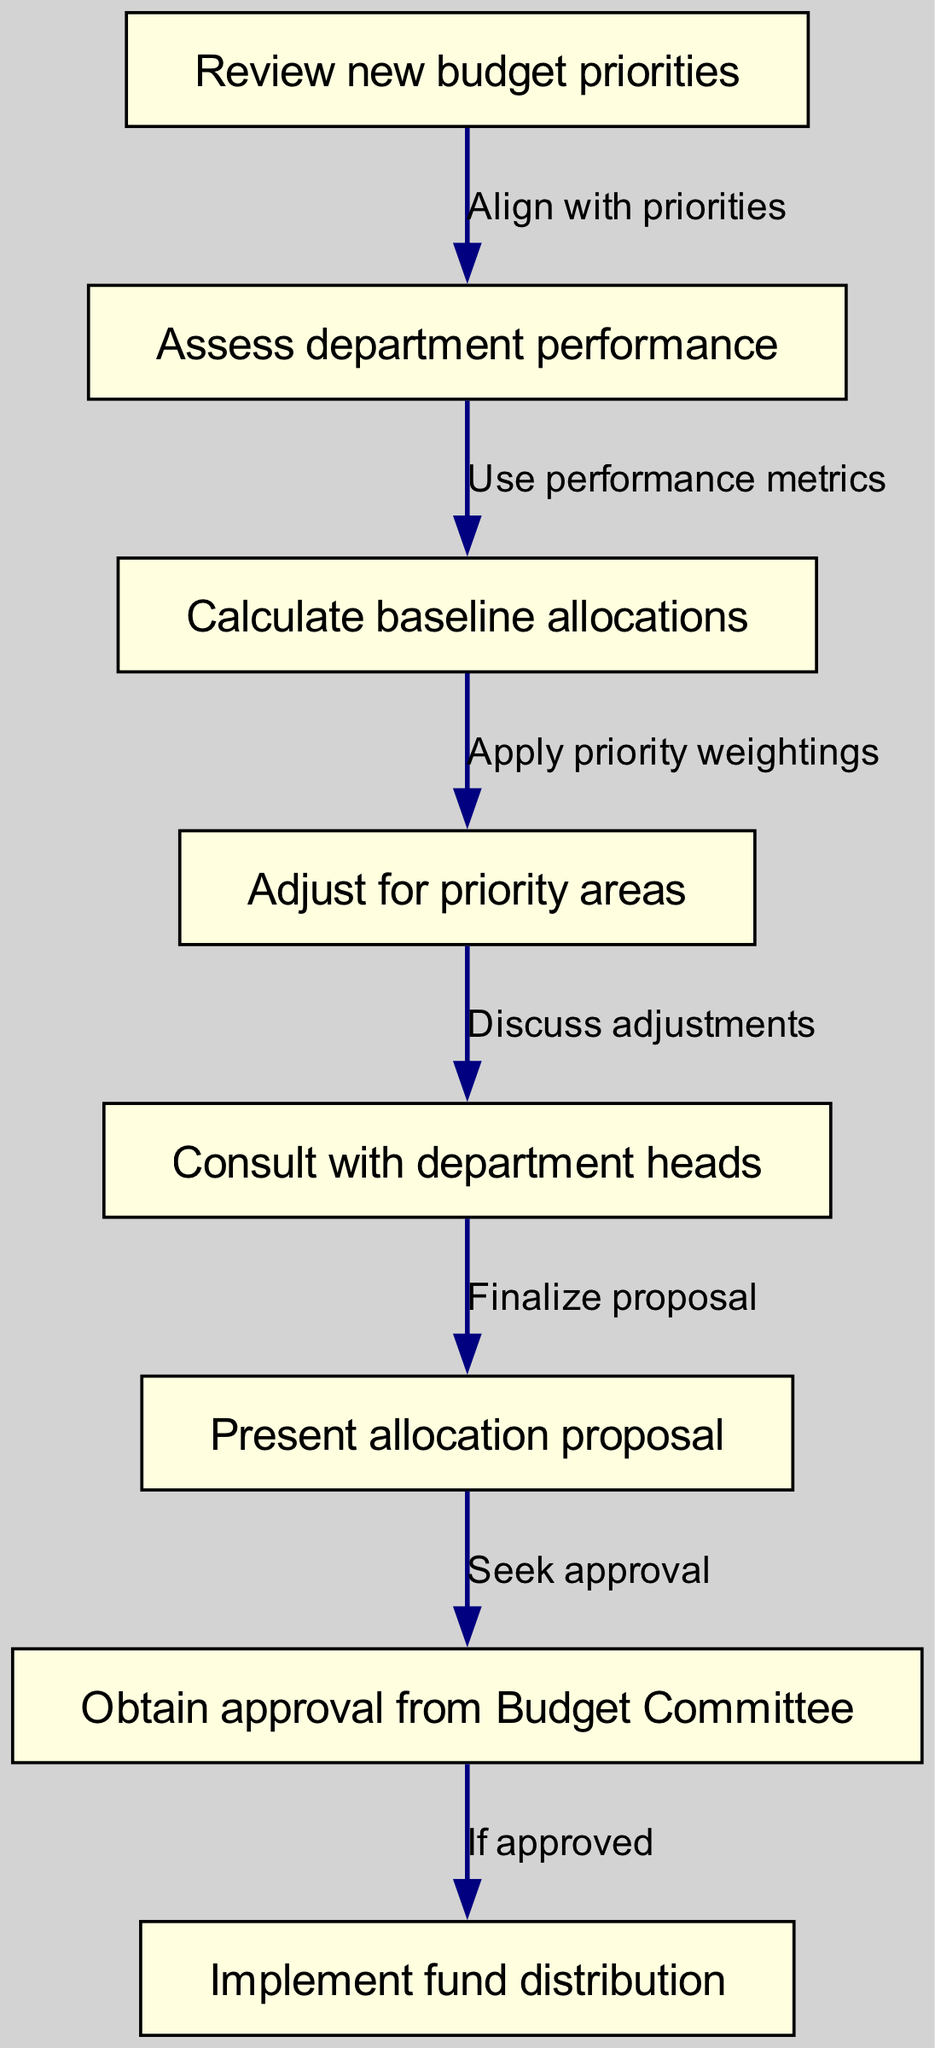What is the first step in the workflow? The first node in the diagram is "Review new budget priorities", which clearly indicates the initial action taken in this workflow.
Answer: Review new budget priorities How many nodes are present in this diagram? By counting the distinct entries listed in the "nodes" section, there are a total of eight nodes in the workflow diagram.
Answer: 8 What is the relationship between "Assess department performance" and "Calculate baseline allocations"? The edge connecting these two nodes states "Use performance metrics", showing that assessing performance directly influences the calculation of baseline allocations.
Answer: Use performance metrics What is the final step to be taken in this workflow? The last node in the diagram is "Implement fund distribution", indicating that this is the concluding action of the process.
Answer: Implement fund distribution Which step comes after "Consult with department heads"? Following the "Consult with department heads" node, the next step as indicated by the connecting edge is "Present allocation proposal".
Answer: Present allocation proposal If the proposal is approved, what is the subsequent action? The diagram indicates that "Implement fund distribution" follows "Obtain approval from Budget Committee" if the proposal is approved.
Answer: Implement fund distribution What identifies the adjustments needed in the funding allocation? The edge leading from "Adjust for priority areas" to "Consult with department heads" signifies that discussions will occur to determine these needed adjustments.
Answer: Discuss adjustments How many edges connect the nodes in the workflow? By analyzing the connecting relationships between nodes, there are a total of seven edges outlined in the diagram that link the different steps together.
Answer: 7 